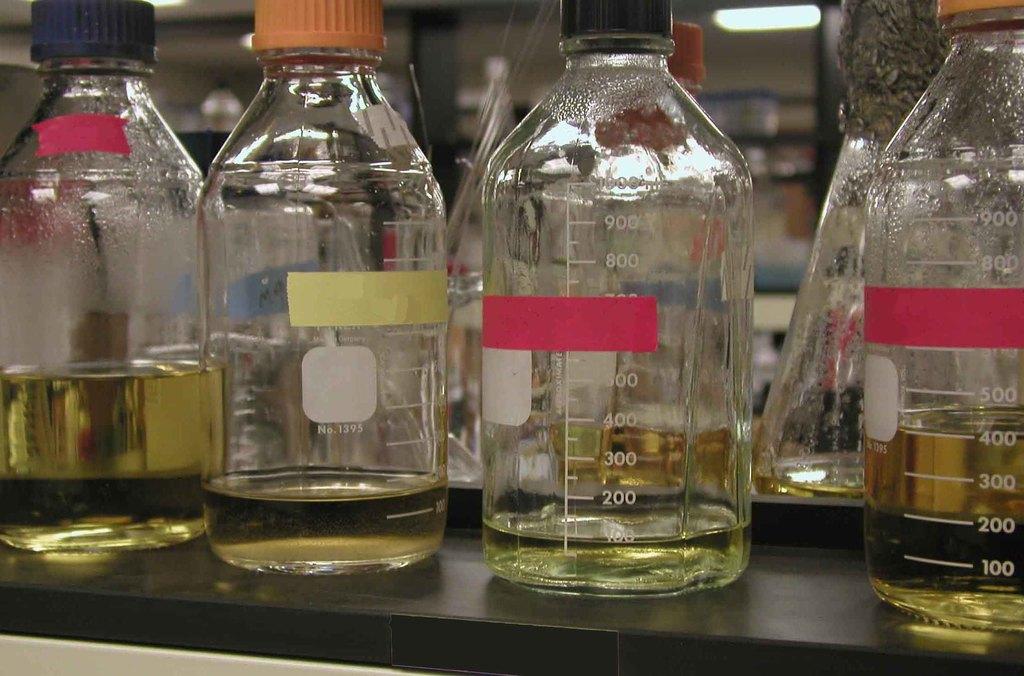Does this go up to 900?
Your answer should be very brief. Yes. What is the lowest unit measurement is displayed on the bottle?
Keep it short and to the point. 100. 